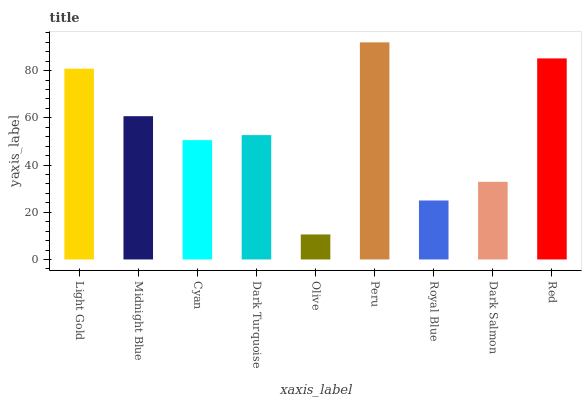Is Olive the minimum?
Answer yes or no. Yes. Is Peru the maximum?
Answer yes or no. Yes. Is Midnight Blue the minimum?
Answer yes or no. No. Is Midnight Blue the maximum?
Answer yes or no. No. Is Light Gold greater than Midnight Blue?
Answer yes or no. Yes. Is Midnight Blue less than Light Gold?
Answer yes or no. Yes. Is Midnight Blue greater than Light Gold?
Answer yes or no. No. Is Light Gold less than Midnight Blue?
Answer yes or no. No. Is Dark Turquoise the high median?
Answer yes or no. Yes. Is Dark Turquoise the low median?
Answer yes or no. Yes. Is Cyan the high median?
Answer yes or no. No. Is Midnight Blue the low median?
Answer yes or no. No. 